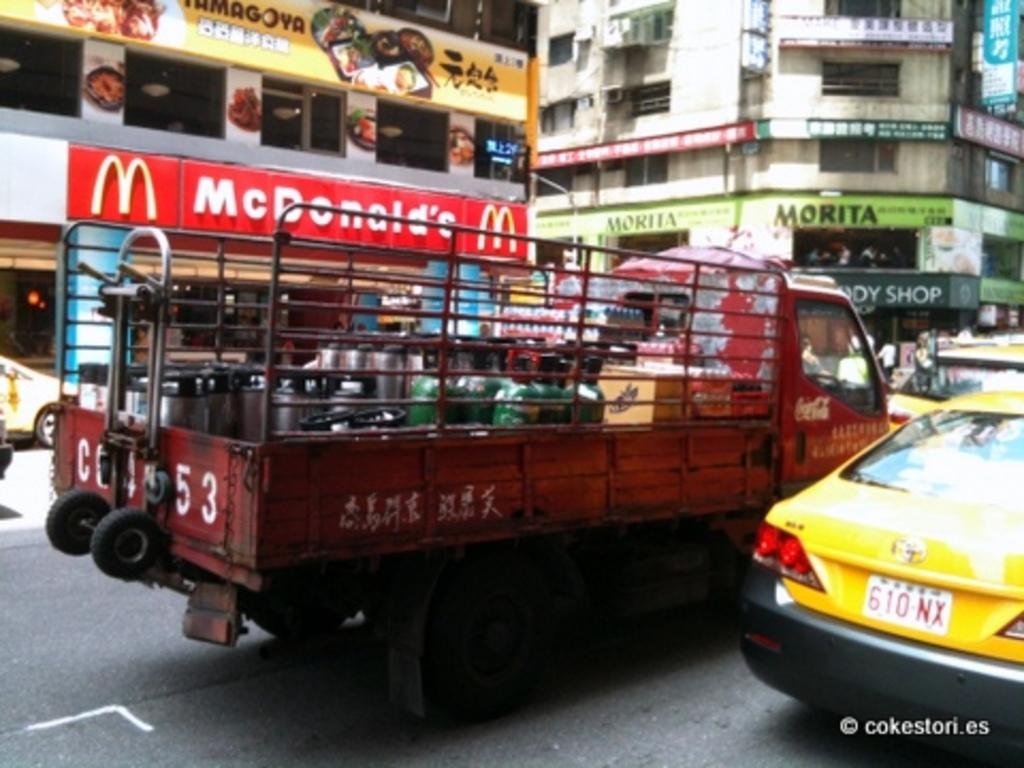<image>
Relay a brief, clear account of the picture shown. Some vehicles in front of a Mc Donald's restaurant 